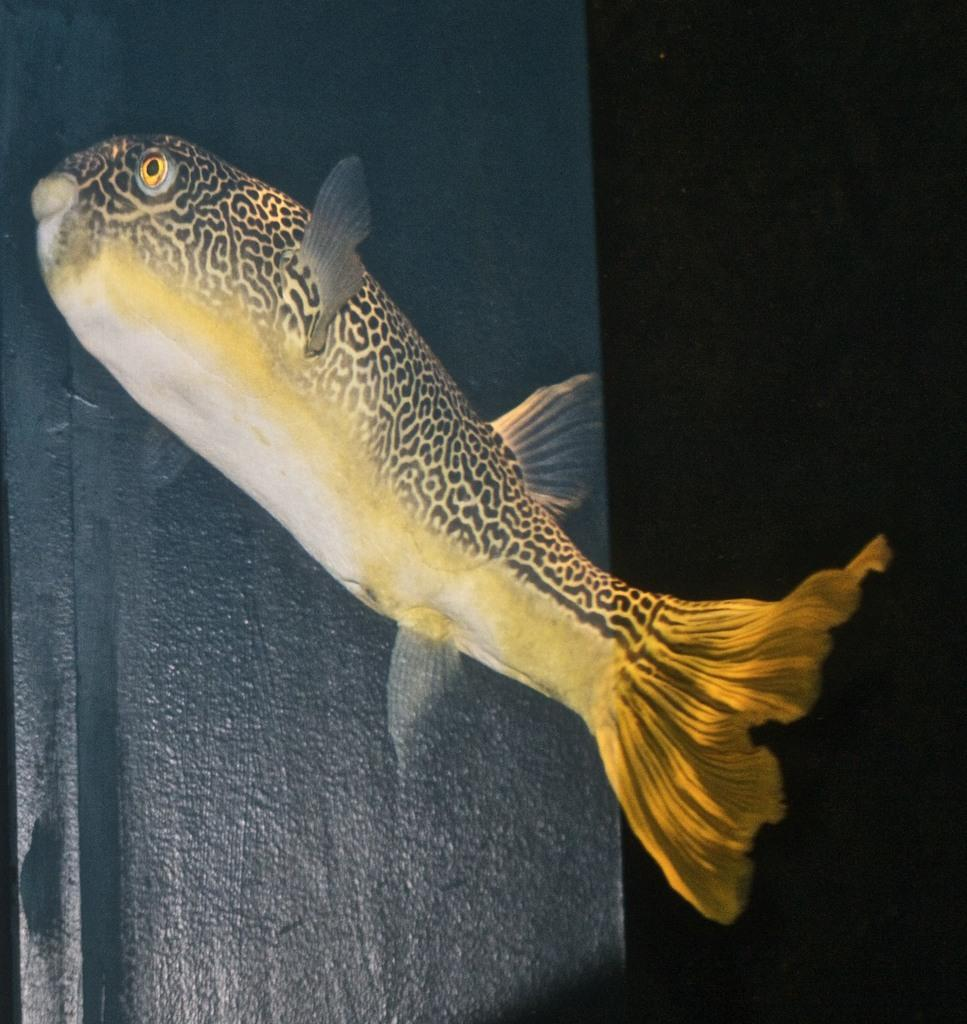What is the main subject of the image? There is a fish in the image. What is the fish doing in the image? The fish appears to be swimming in a water body. Can you describe the background of the image? There is a black color object in the background of the image. How many hands are holding the rod in the image? There is no rod or hands present in the image; it only features a fish swimming in a water body and a black color object in the background. 